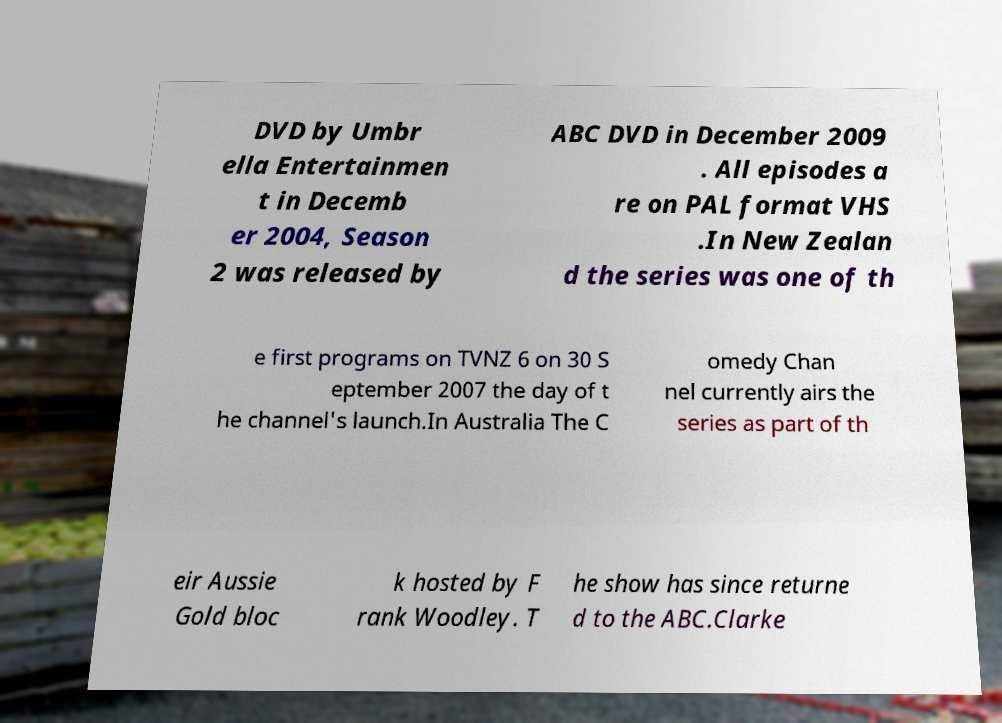For documentation purposes, I need the text within this image transcribed. Could you provide that? DVD by Umbr ella Entertainmen t in Decemb er 2004, Season 2 was released by ABC DVD in December 2009 . All episodes a re on PAL format VHS .In New Zealan d the series was one of th e first programs on TVNZ 6 on 30 S eptember 2007 the day of t he channel's launch.In Australia The C omedy Chan nel currently airs the series as part of th eir Aussie Gold bloc k hosted by F rank Woodley. T he show has since returne d to the ABC.Clarke 